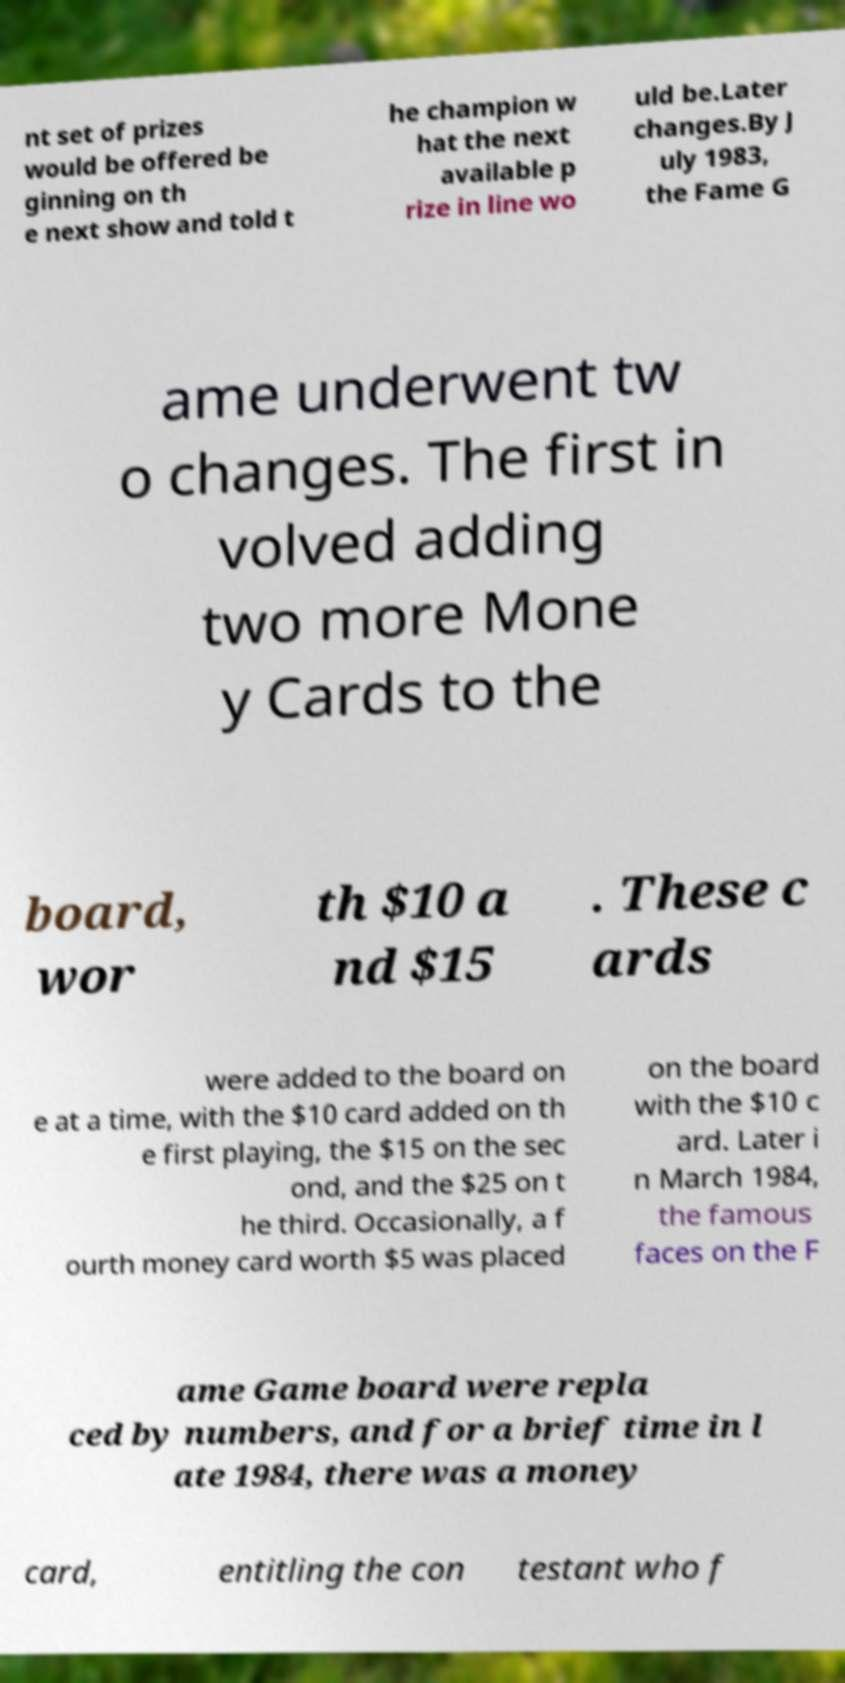Please read and relay the text visible in this image. What does it say? nt set of prizes would be offered be ginning on th e next show and told t he champion w hat the next available p rize in line wo uld be.Later changes.By J uly 1983, the Fame G ame underwent tw o changes. The first in volved adding two more Mone y Cards to the board, wor th $10 a nd $15 . These c ards were added to the board on e at a time, with the $10 card added on th e first playing, the $15 on the sec ond, and the $25 on t he third. Occasionally, a f ourth money card worth $5 was placed on the board with the $10 c ard. Later i n March 1984, the famous faces on the F ame Game board were repla ced by numbers, and for a brief time in l ate 1984, there was a money card, entitling the con testant who f 